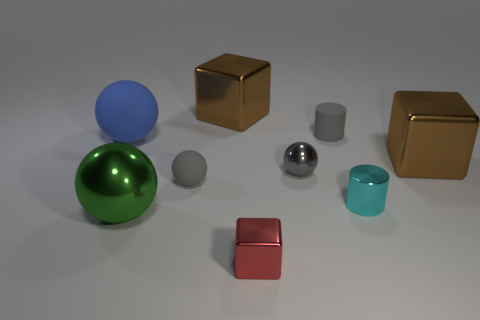Subtract all brown cubes. How many were subtracted if there are1brown cubes left? 1 Subtract all cyan cylinders. Subtract all yellow balls. How many cylinders are left? 1 Subtract all blocks. How many objects are left? 6 Add 5 tiny gray rubber spheres. How many tiny gray rubber spheres are left? 6 Add 1 cyan cylinders. How many cyan cylinders exist? 2 Subtract 1 blue balls. How many objects are left? 8 Subtract all blue balls. Subtract all matte cylinders. How many objects are left? 7 